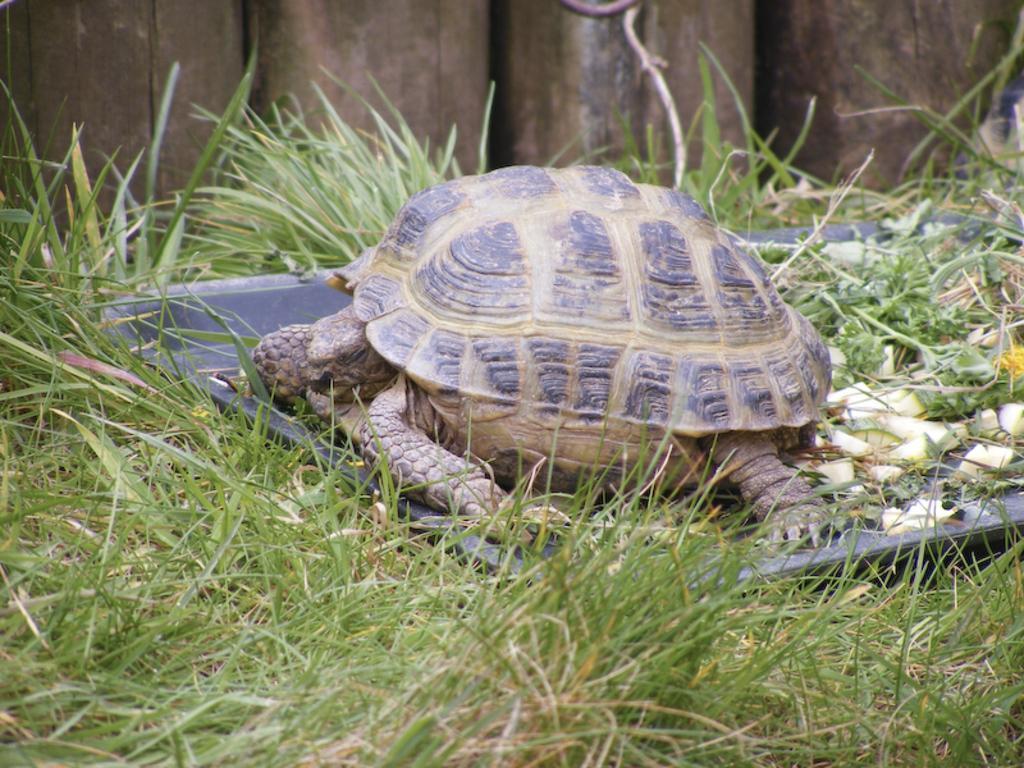Describe this image in one or two sentences. In this image I can see in the middle it is a tortoise, at the bottom there is the grass. 